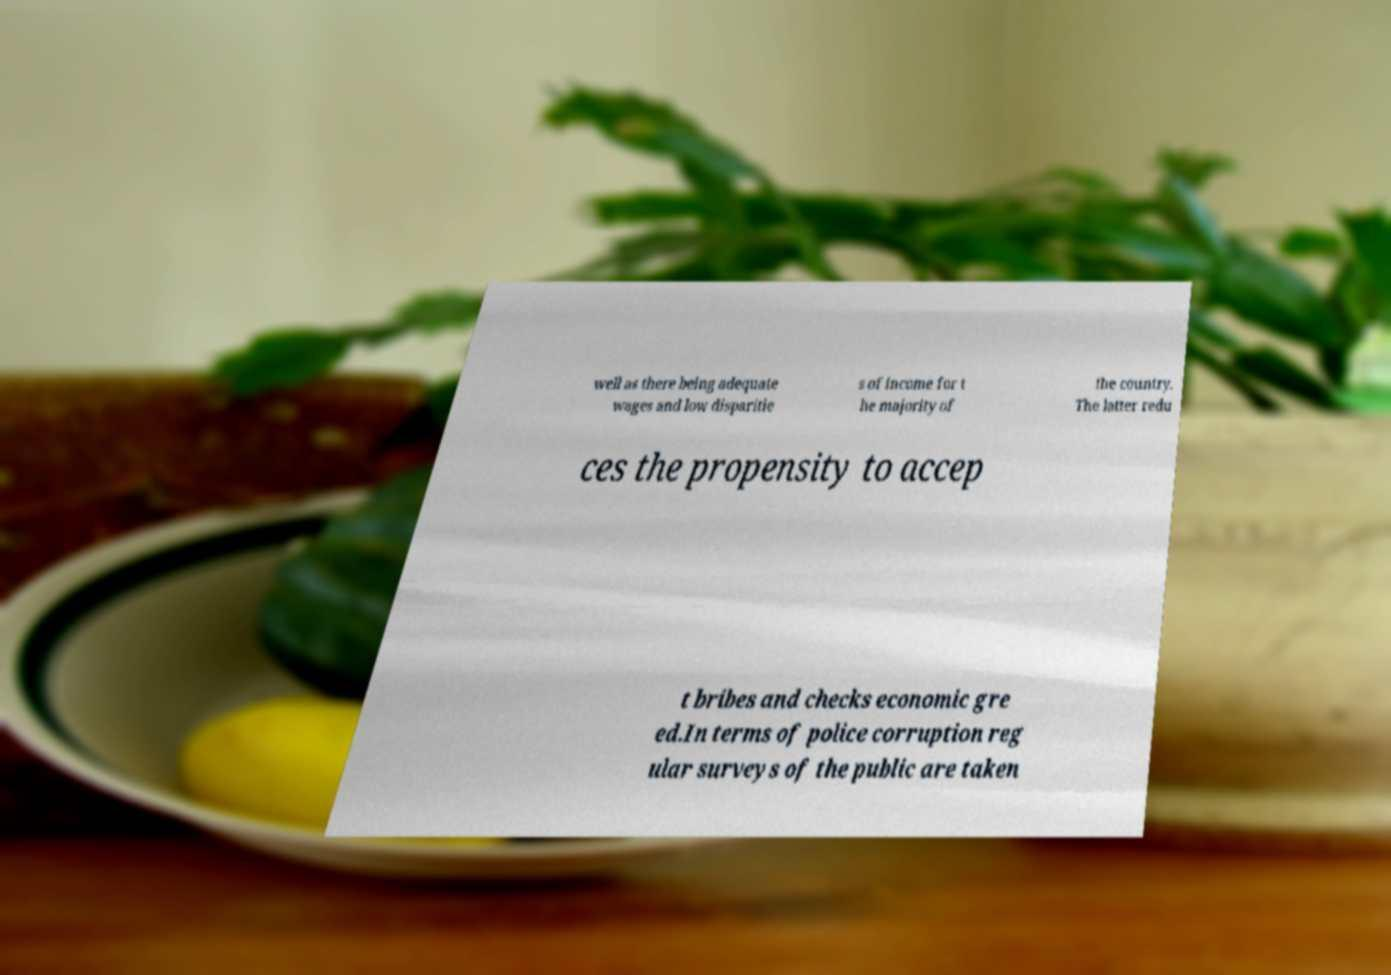For documentation purposes, I need the text within this image transcribed. Could you provide that? well as there being adequate wages and low disparitie s of income for t he majority of the country. The latter redu ces the propensity to accep t bribes and checks economic gre ed.In terms of police corruption reg ular surveys of the public are taken 